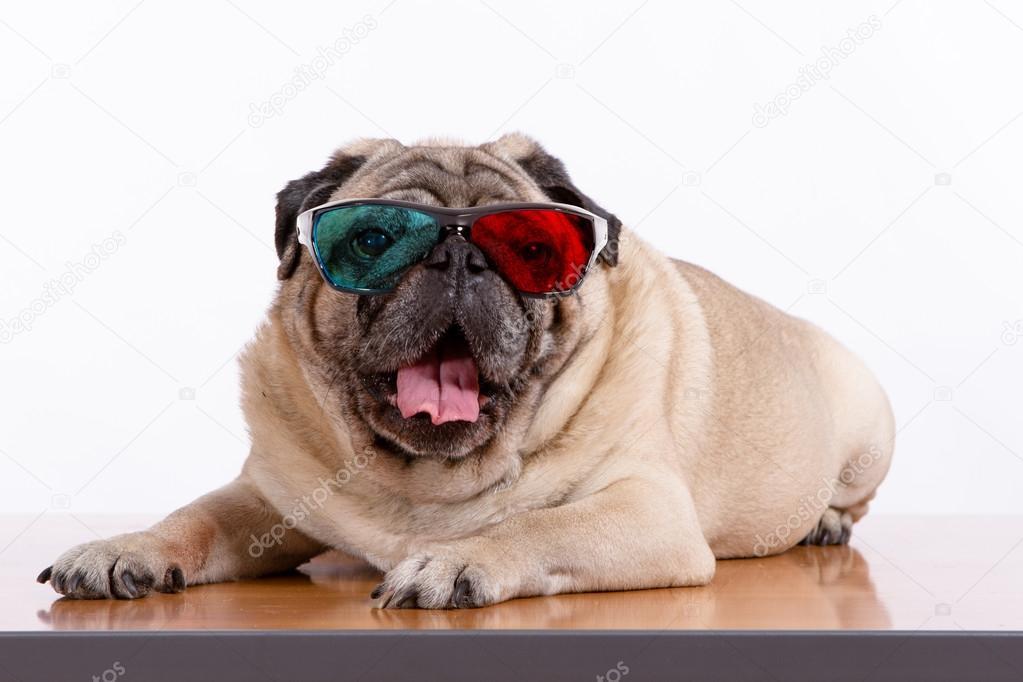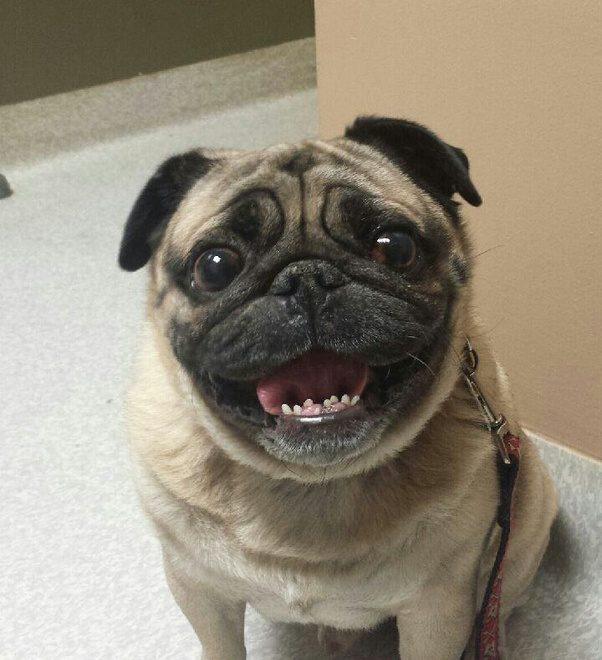The first image is the image on the left, the second image is the image on the right. For the images displayed, is the sentence "Not even one dog has it's mouth open." factually correct? Answer yes or no. No. 